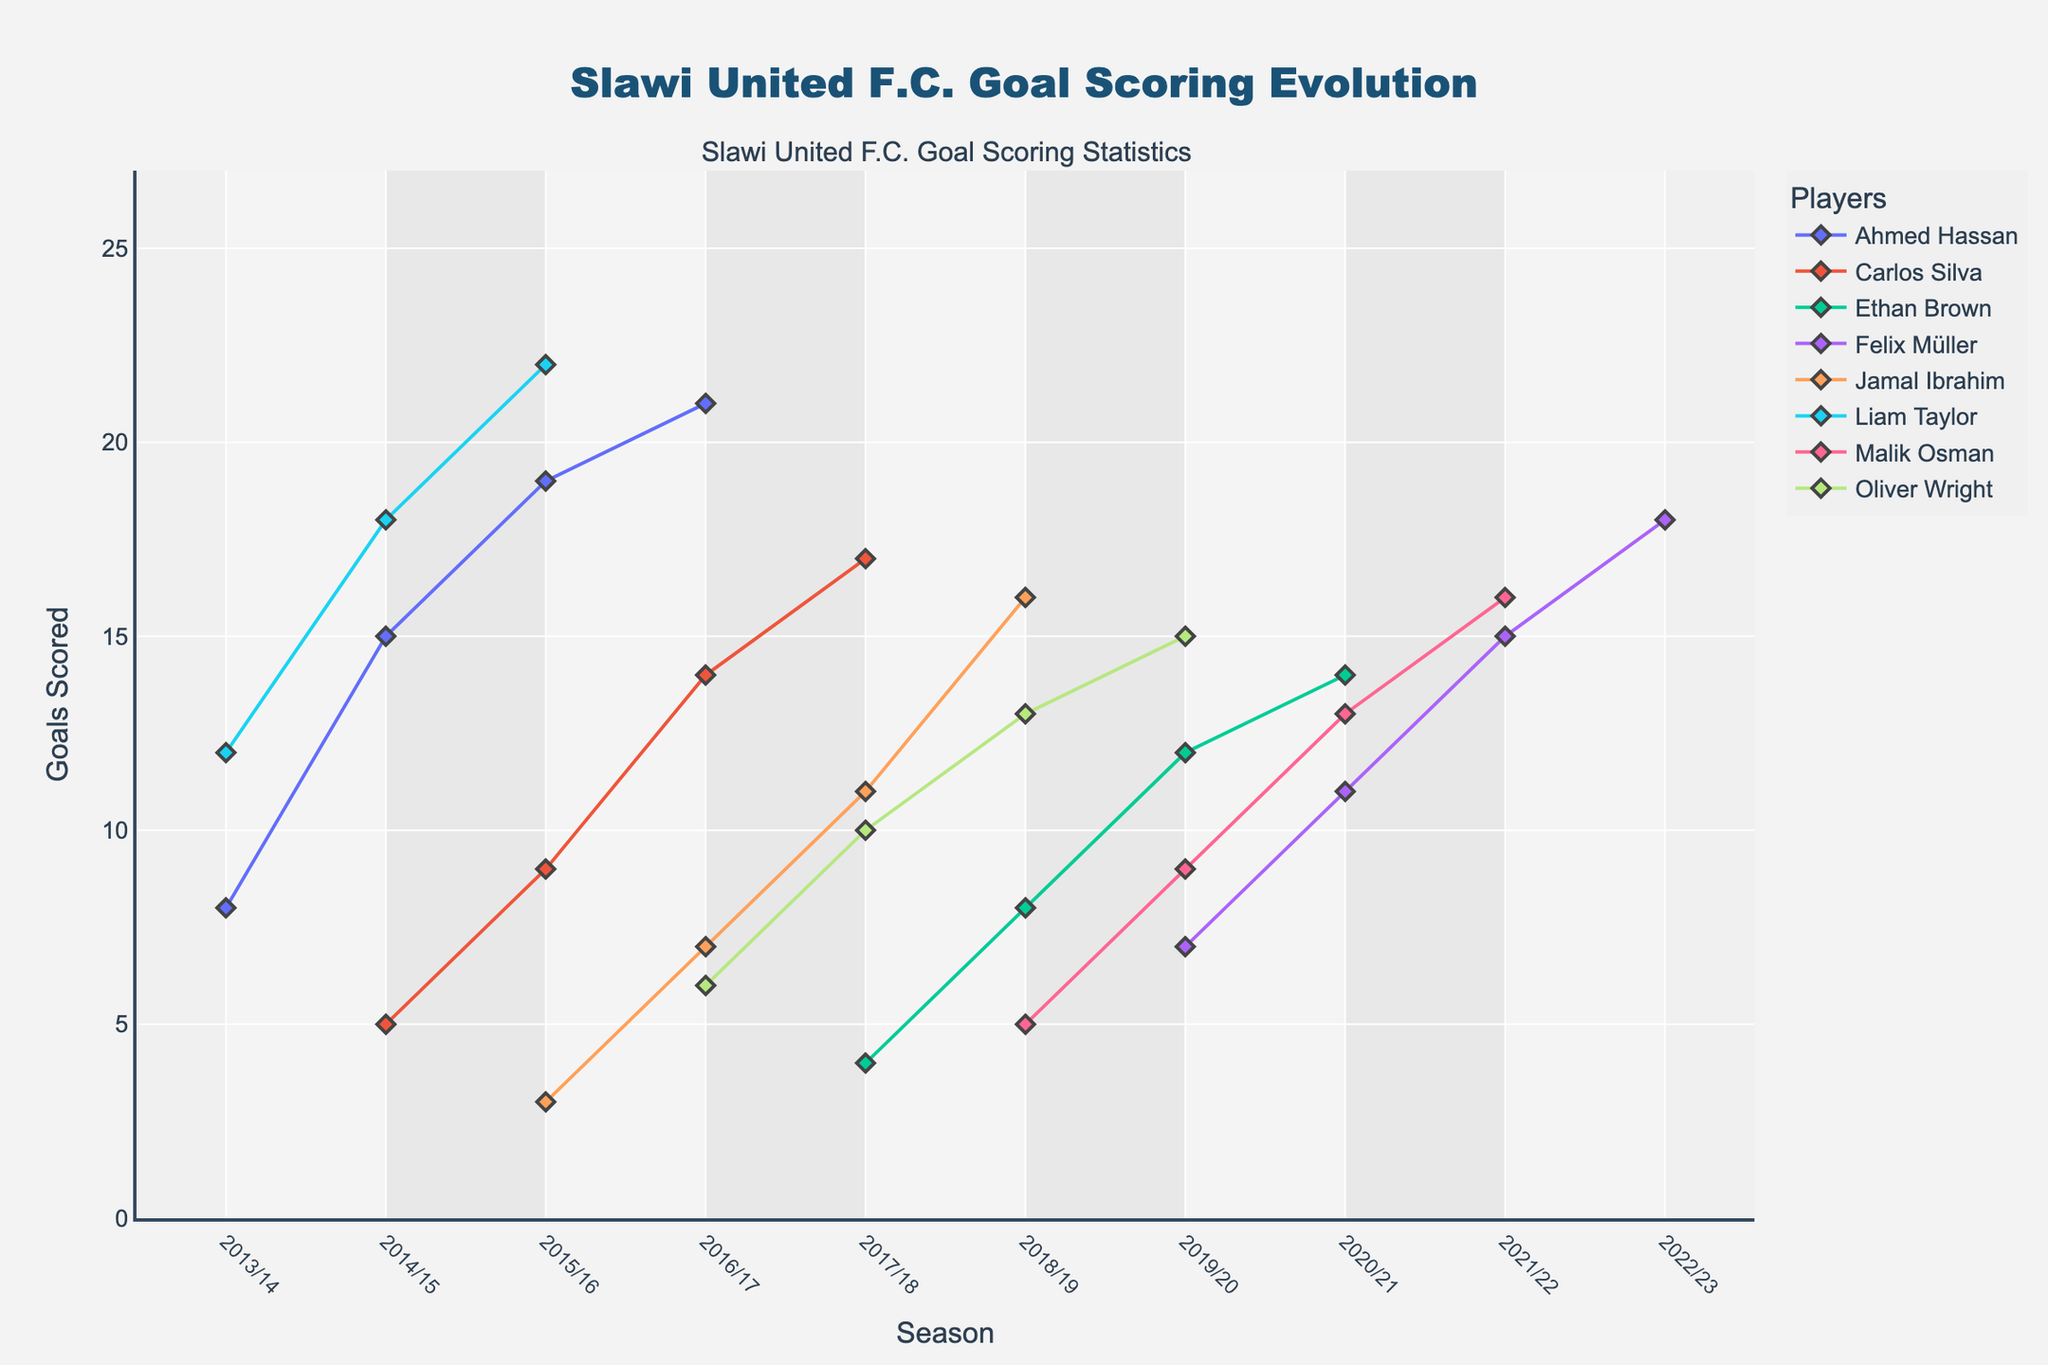What is the title of the plot? The title is usually shown at the very top of a plot, often in a larger and bold font. In this case, the plot's title is clearly stated at the top.
Answer: Slawi United F.C. Goal Scoring Evolution Which player scored the most goals in the 2015/16 season? To identify this, look at the data points corresponding to the 2015/16 season and find the highest value. Liam Taylor has the highest data point among all players.
Answer: Liam Taylor How did Ahmed Hassan's goal-scoring trend change over the observed seasons? Track Ahmed Hassan's data points across the seasons. He starts with 8 goals in 2013/14, gradually increases his goals each season, peaking in 2016/17 with 21 goals.
Answer: Increasing Which player has the most consistent goal-scoring trend? To determine consistency, look for players whose goal-scoring lines are the smoothest or have the least variation. Ahmed Hassan shows a steady increase without large fluctuations.
Answer: Ahmed Hassan During which season did Carlos Silva have his highest goal count, and what was it? Locate the peak in Carlos Silva’s goal-scoring history, which appears around the 2017/18 season, then check the corresponding value.
Answer: 2017/18, 17 goals How many players scored more than 15 goals in any single season? Count the individual seasons where players exceed 15 goals. Liam Taylor, Ahmed Hassan, along with Felix Müller and Malik Osman, have seasons with more than 15 goals.
Answer: 4 players Who is the player with the least total goals scored across all seasons? Sum the goals across all seasons for each player and compare. Jamal Ibrahim, after summing, shows the least number of total goals.
Answer: Jamal Ibrahim Compare the goals scored by Felix Müller in the 2019/20 season to Ethan Brown in the 2020/21 season. Who scored more? Check the data points for both players in the specified seasons. Felix Müller had 7 goals in 2019/20, Ethan Brown had 14 in 2020/21.
Answer: Ethan Brown What’s the average number of goals scored by Oliver Wright per season? Sum all of Oliver Wright’s goals and divide by the number of seasons he played. He scored 6+10+13+15 = 44 goals over 4 seasons, so the average is 44/4.
Answer: 11 